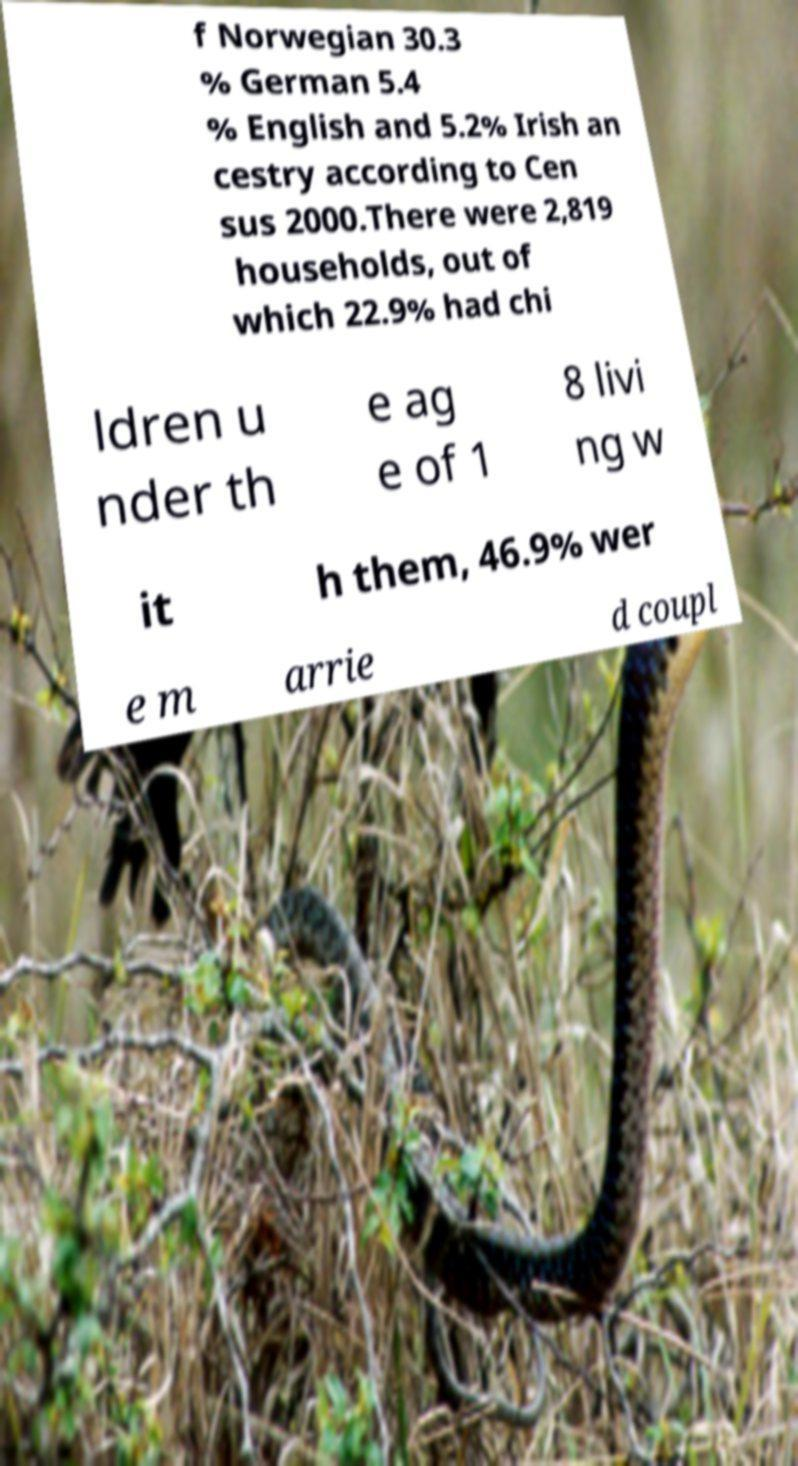Can you read and provide the text displayed in the image?This photo seems to have some interesting text. Can you extract and type it out for me? f Norwegian 30.3 % German 5.4 % English and 5.2% Irish an cestry according to Cen sus 2000.There were 2,819 households, out of which 22.9% had chi ldren u nder th e ag e of 1 8 livi ng w it h them, 46.9% wer e m arrie d coupl 